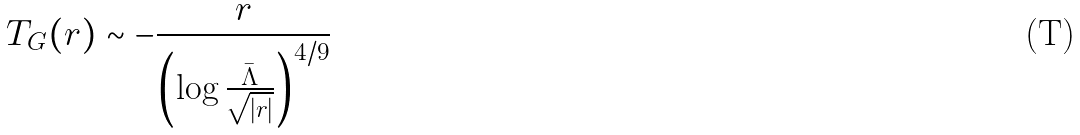Convert formula to latex. <formula><loc_0><loc_0><loc_500><loc_500>T _ { G } ( r ) \sim - \frac { r } { \left ( \log \frac { \bar { \Lambda } } { \sqrt { | r | } } \right ) ^ { 4 / 9 } }</formula> 